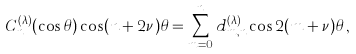Convert formula to latex. <formula><loc_0><loc_0><loc_500><loc_500>C _ { n } ^ { ( \lambda ) } ( \cos \theta ) \cos ( n + 2 \nu ) \theta = \sum _ { m = 0 } ^ { n } d _ { m , n } ^ { ( \lambda ) } \cos 2 ( m + \nu ) \theta \, ,</formula> 